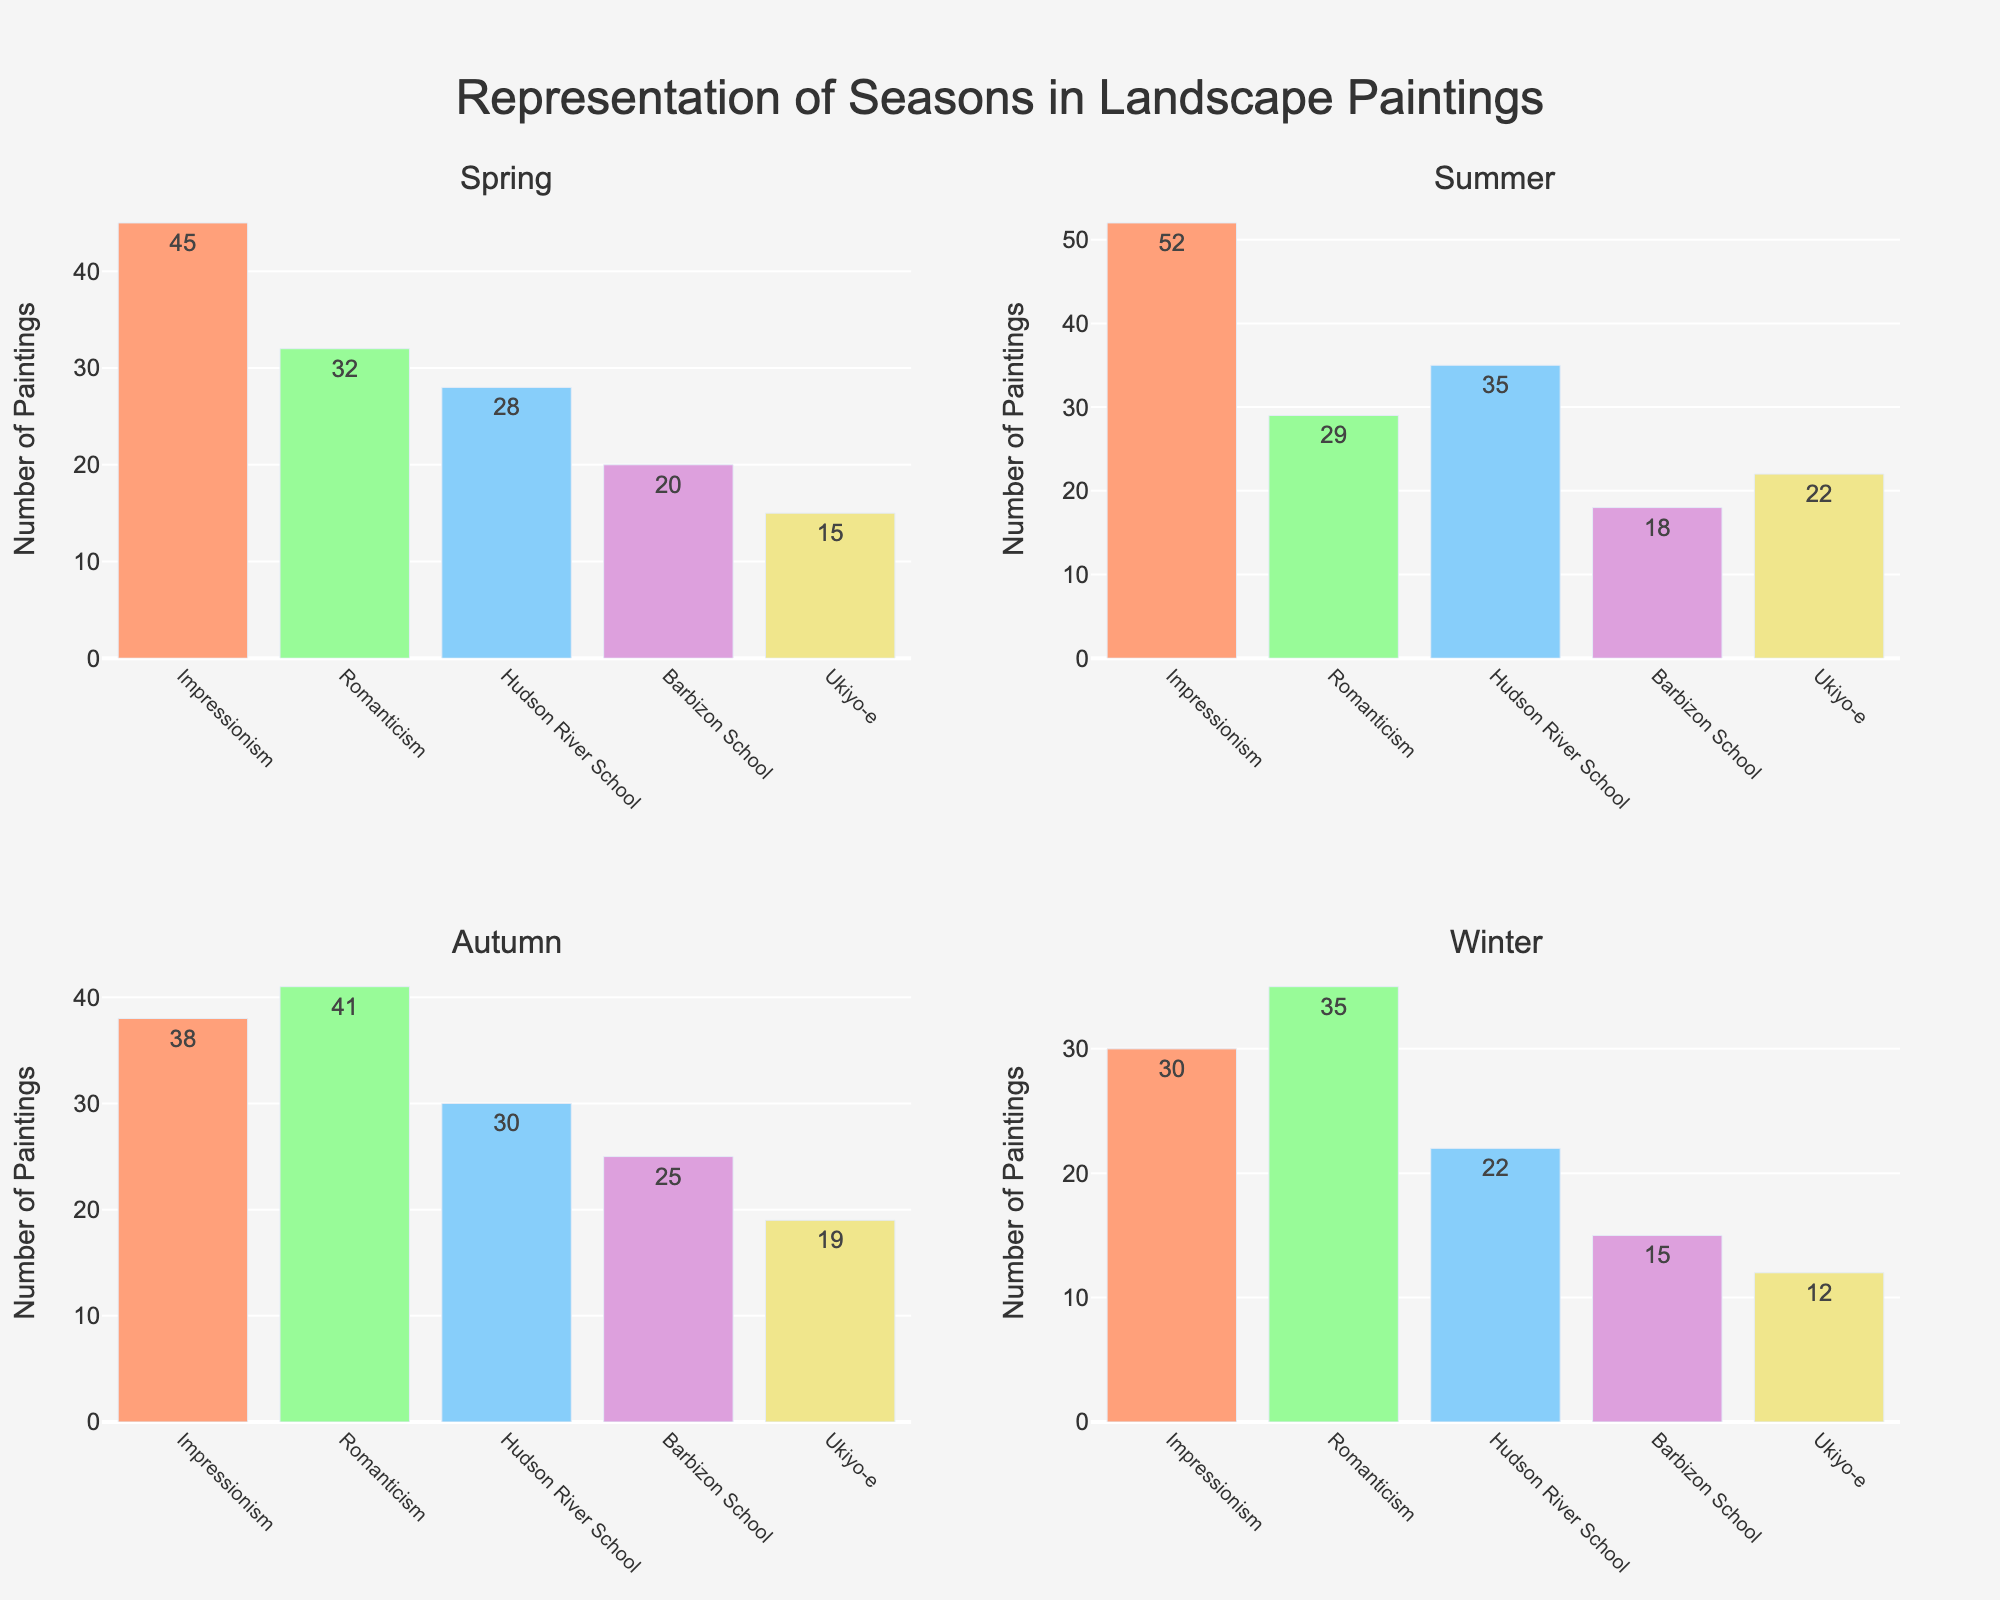What is the title of the figure? The title of the figure is typically located at the top and is explicitly mentioned in the plot as a prominent text.
Answer: Representation of Seasons in Landscape Paintings Which art movement has the highest number of spring paintings? For the Spring subplot, look for the bar that extends the highest. The Impressionism bar is the tallest for Spring season.
Answer: Impressionism How many paintings represent Winter in the Romanticism art movement? Locate the Winter subplot and check the bar corresponding to the Romanticism art movement. The bar is labeled with the number 35.
Answer: 35 Which season has the least number of paintings in the Barbizon School art movement? Look at the heights of all Barbizon School bars across each seasonal subplot. The Winter bar is the shortest.
Answer: Winter What is the total number of paintings representing Autumn across all art movements? Sum the values for all bars in the Autumn subplot: 38 (Impressionism) + 41 (Romanticism) + 30 (Hudson River School) + 25 (Barbizon School) + 19 (Ukiyo-e) = 153
Answer: 153 Which season is represented by the fewest paintings in the Ukiyo-e art movement? Compare the heights of Ukiyo-e bars across all subplots. The Winter bar is the shortest.
Answer: Winter How many more summer paintings are there in the Hudson River School compared to the Barbizon School? Find the number of summer paintings for both Hudson River School (35) and Barbizon School (18), then subtract: 35 - 18 = 17
Answer: 17 In which season is the discrepancy between the number of paintings for Impressionism and Ukiyo-e the largest? Calculate the differences for each season: Spring (45 - 15 = 30), Summer (52 - 22 = 30), Autumn (38 - 19 = 19), Winter (30 - 12 = 18). The largest discrepancy of 30 occurs in both Spring and Summer.
Answer: Spring and Summer Which art movement consistently has a similar number of paintings across all seasons? Look for art movements with bars of roughly equal heights across all subplots. The Romanticism bars are relatively consistent.
Answer: Romanticism 